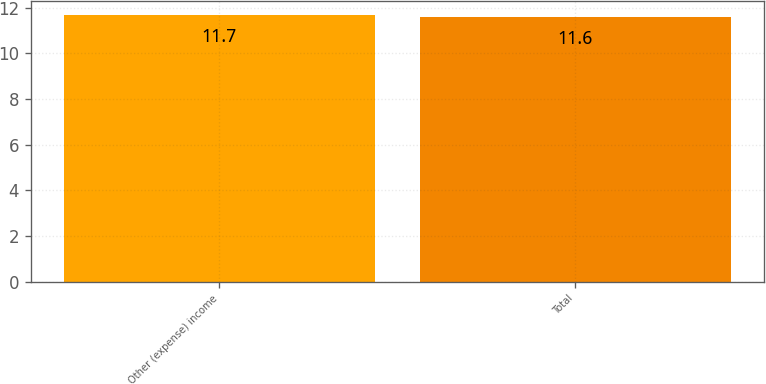Convert chart. <chart><loc_0><loc_0><loc_500><loc_500><bar_chart><fcel>Other (expense) income<fcel>Total<nl><fcel>11.7<fcel>11.6<nl></chart> 